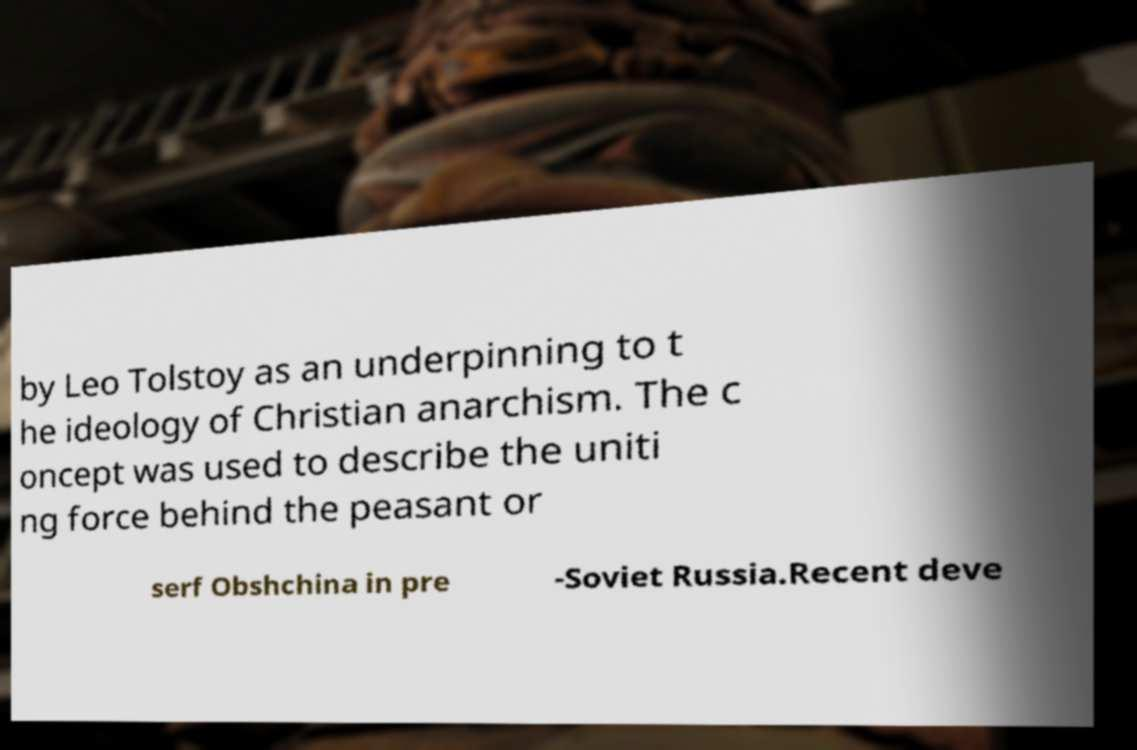There's text embedded in this image that I need extracted. Can you transcribe it verbatim? by Leo Tolstoy as an underpinning to t he ideology of Christian anarchism. The c oncept was used to describe the uniti ng force behind the peasant or serf Obshchina in pre -Soviet Russia.Recent deve 